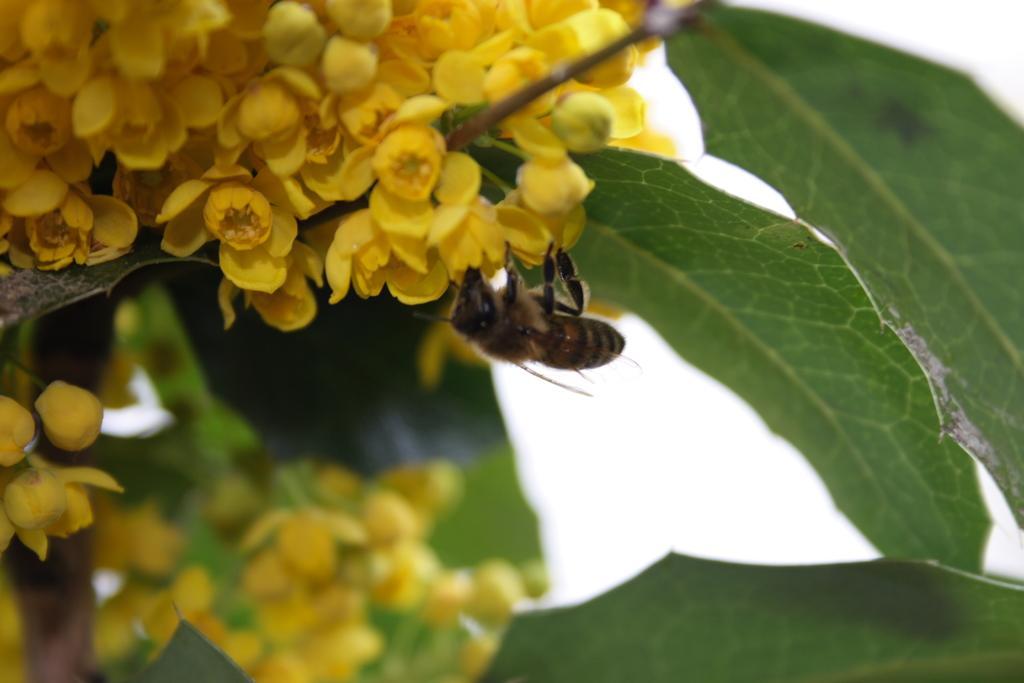In one or two sentences, can you explain what this image depicts? In this image there are flowers and we can see a bee on the flowers. There are leaves. In the background we can see sky. 